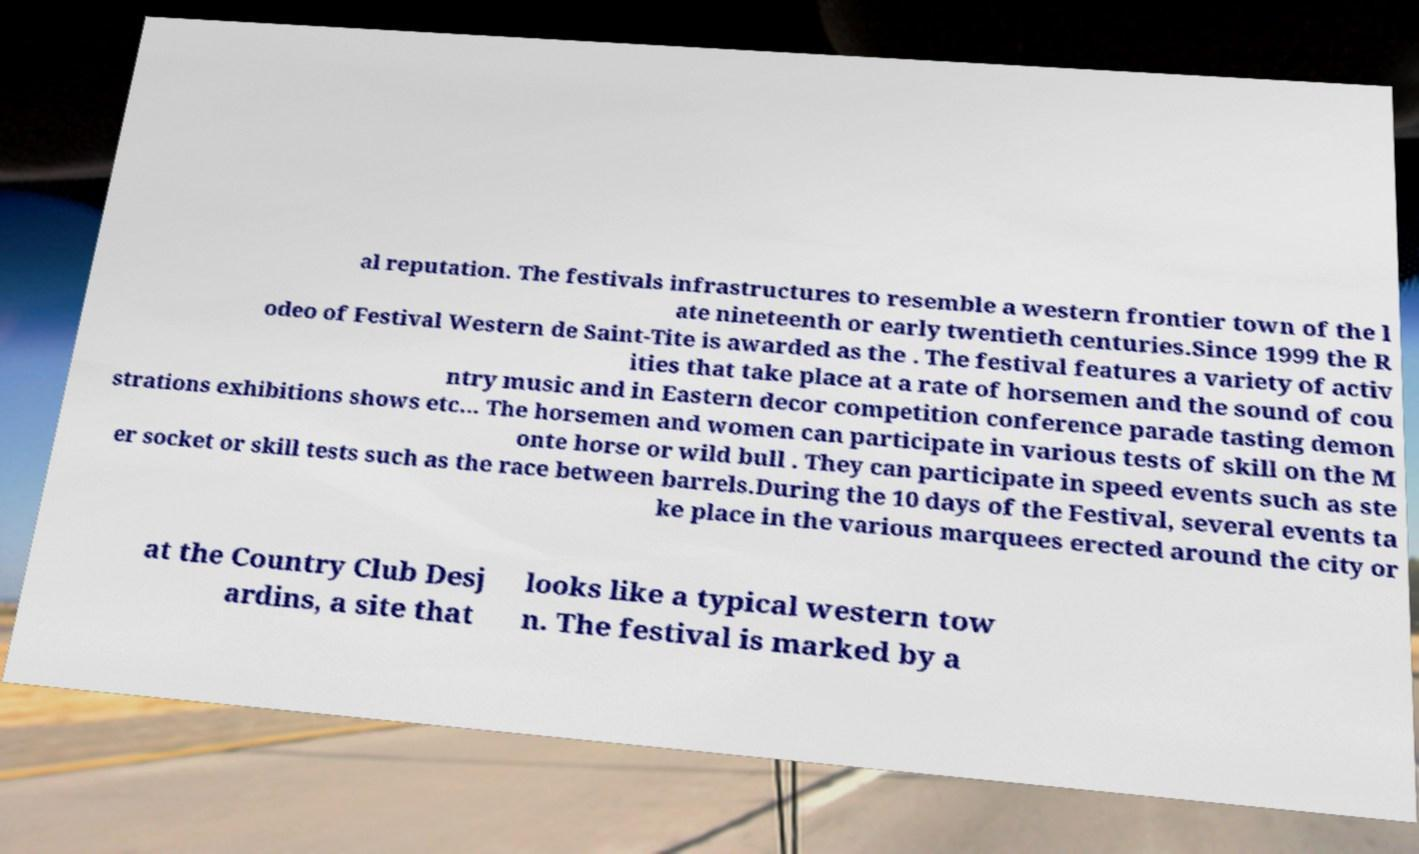I need the written content from this picture converted into text. Can you do that? al reputation. The festivals infrastructures to resemble a western frontier town of the l ate nineteenth or early twentieth centuries.Since 1999 the R odeo of Festival Western de Saint-Tite is awarded as the . The festival features a variety of activ ities that take place at a rate of horsemen and the sound of cou ntry music and in Eastern decor competition conference parade tasting demon strations exhibitions shows etc... The horsemen and women can participate in various tests of skill on the M onte horse or wild bull . They can participate in speed events such as ste er socket or skill tests such as the race between barrels.During the 10 days of the Festival, several events ta ke place in the various marquees erected around the city or at the Country Club Desj ardins, a site that looks like a typical western tow n. The festival is marked by a 